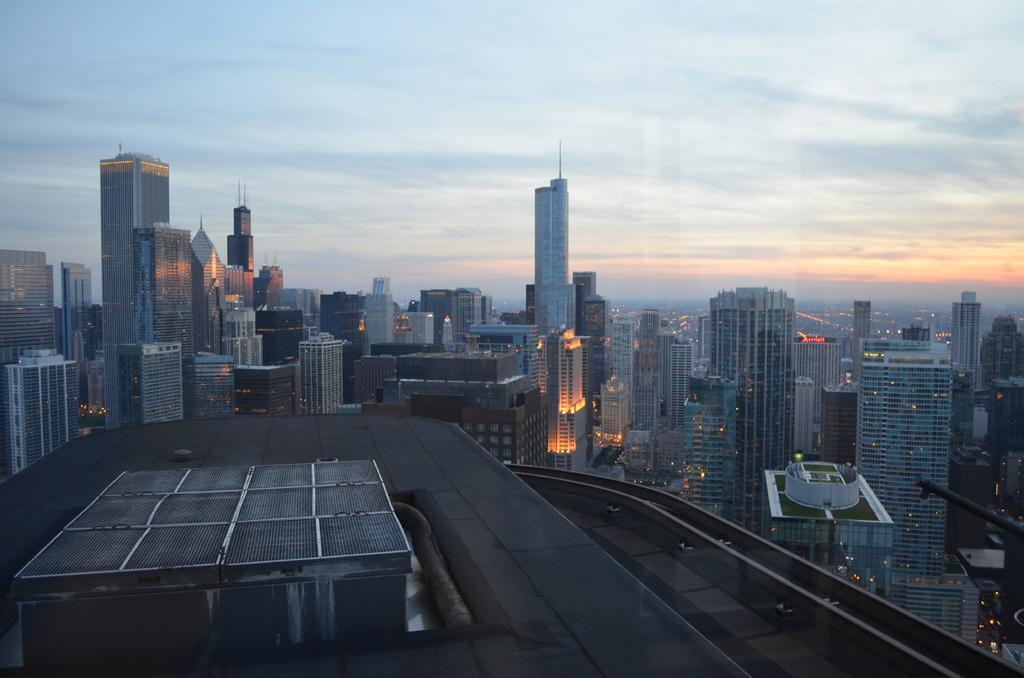What is the main subject of the image? The main subject of the image is a group of buildings. Can you describe any specific features of the buildings? The provided facts do not mention any specific features of the buildings. What else can be seen in the image besides the buildings? Lights are visible in the image. What is visible in the background of the image? The sky is visible in the background of the image. How many kittens can be seen stretching in the image? There are no kittens present in the image. What type of shame is depicted in the image? There is no shame depicted in the image; it features a group of buildings and lights. 